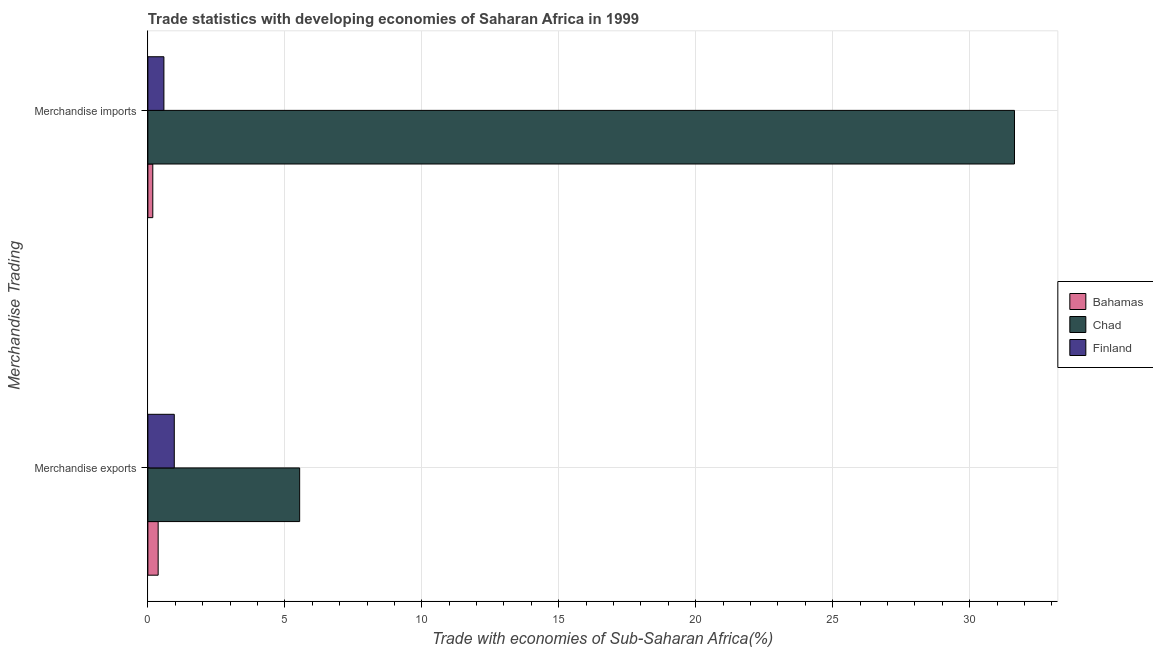How many bars are there on the 2nd tick from the top?
Your response must be concise. 3. What is the label of the 2nd group of bars from the top?
Give a very brief answer. Merchandise exports. What is the merchandise exports in Bahamas?
Your answer should be very brief. 0.38. Across all countries, what is the maximum merchandise imports?
Ensure brevity in your answer.  31.64. Across all countries, what is the minimum merchandise exports?
Give a very brief answer. 0.38. In which country was the merchandise imports maximum?
Provide a succinct answer. Chad. In which country was the merchandise imports minimum?
Keep it short and to the point. Bahamas. What is the total merchandise imports in the graph?
Your response must be concise. 32.4. What is the difference between the merchandise imports in Bahamas and that in Chad?
Offer a very short reply. -31.46. What is the difference between the merchandise exports in Finland and the merchandise imports in Bahamas?
Provide a succinct answer. 0.78. What is the average merchandise imports per country?
Offer a terse response. 10.8. What is the difference between the merchandise exports and merchandise imports in Chad?
Your response must be concise. -26.1. In how many countries, is the merchandise exports greater than 18 %?
Provide a short and direct response. 0. What is the ratio of the merchandise imports in Bahamas to that in Chad?
Offer a terse response. 0.01. In how many countries, is the merchandise exports greater than the average merchandise exports taken over all countries?
Offer a very short reply. 1. What does the 3rd bar from the top in Merchandise imports represents?
Provide a succinct answer. Bahamas. How many bars are there?
Ensure brevity in your answer.  6. What is the difference between two consecutive major ticks on the X-axis?
Make the answer very short. 5. Are the values on the major ticks of X-axis written in scientific E-notation?
Give a very brief answer. No. Does the graph contain grids?
Your answer should be compact. Yes. Where does the legend appear in the graph?
Give a very brief answer. Center right. How are the legend labels stacked?
Offer a very short reply. Vertical. What is the title of the graph?
Your answer should be very brief. Trade statistics with developing economies of Saharan Africa in 1999. Does "Lebanon" appear as one of the legend labels in the graph?
Offer a very short reply. No. What is the label or title of the X-axis?
Offer a very short reply. Trade with economies of Sub-Saharan Africa(%). What is the label or title of the Y-axis?
Your answer should be compact. Merchandise Trading. What is the Trade with economies of Sub-Saharan Africa(%) of Bahamas in Merchandise exports?
Offer a very short reply. 0.38. What is the Trade with economies of Sub-Saharan Africa(%) in Chad in Merchandise exports?
Your answer should be very brief. 5.54. What is the Trade with economies of Sub-Saharan Africa(%) in Finland in Merchandise exports?
Your response must be concise. 0.96. What is the Trade with economies of Sub-Saharan Africa(%) of Bahamas in Merchandise imports?
Provide a succinct answer. 0.18. What is the Trade with economies of Sub-Saharan Africa(%) of Chad in Merchandise imports?
Keep it short and to the point. 31.64. What is the Trade with economies of Sub-Saharan Africa(%) in Finland in Merchandise imports?
Give a very brief answer. 0.59. Across all Merchandise Trading, what is the maximum Trade with economies of Sub-Saharan Africa(%) of Bahamas?
Provide a short and direct response. 0.38. Across all Merchandise Trading, what is the maximum Trade with economies of Sub-Saharan Africa(%) in Chad?
Provide a short and direct response. 31.64. Across all Merchandise Trading, what is the maximum Trade with economies of Sub-Saharan Africa(%) in Finland?
Keep it short and to the point. 0.96. Across all Merchandise Trading, what is the minimum Trade with economies of Sub-Saharan Africa(%) of Bahamas?
Provide a succinct answer. 0.18. Across all Merchandise Trading, what is the minimum Trade with economies of Sub-Saharan Africa(%) in Chad?
Your answer should be compact. 5.54. Across all Merchandise Trading, what is the minimum Trade with economies of Sub-Saharan Africa(%) in Finland?
Make the answer very short. 0.59. What is the total Trade with economies of Sub-Saharan Africa(%) in Bahamas in the graph?
Keep it short and to the point. 0.56. What is the total Trade with economies of Sub-Saharan Africa(%) of Chad in the graph?
Offer a very short reply. 37.18. What is the total Trade with economies of Sub-Saharan Africa(%) in Finland in the graph?
Provide a short and direct response. 1.55. What is the difference between the Trade with economies of Sub-Saharan Africa(%) in Bahamas in Merchandise exports and that in Merchandise imports?
Offer a terse response. 0.2. What is the difference between the Trade with economies of Sub-Saharan Africa(%) of Chad in Merchandise exports and that in Merchandise imports?
Make the answer very short. -26.1. What is the difference between the Trade with economies of Sub-Saharan Africa(%) in Finland in Merchandise exports and that in Merchandise imports?
Make the answer very short. 0.38. What is the difference between the Trade with economies of Sub-Saharan Africa(%) of Bahamas in Merchandise exports and the Trade with economies of Sub-Saharan Africa(%) of Chad in Merchandise imports?
Provide a succinct answer. -31.26. What is the difference between the Trade with economies of Sub-Saharan Africa(%) in Bahamas in Merchandise exports and the Trade with economies of Sub-Saharan Africa(%) in Finland in Merchandise imports?
Your response must be concise. -0.21. What is the difference between the Trade with economies of Sub-Saharan Africa(%) of Chad in Merchandise exports and the Trade with economies of Sub-Saharan Africa(%) of Finland in Merchandise imports?
Offer a terse response. 4.96. What is the average Trade with economies of Sub-Saharan Africa(%) in Bahamas per Merchandise Trading?
Ensure brevity in your answer.  0.28. What is the average Trade with economies of Sub-Saharan Africa(%) of Chad per Merchandise Trading?
Provide a short and direct response. 18.59. What is the average Trade with economies of Sub-Saharan Africa(%) in Finland per Merchandise Trading?
Provide a succinct answer. 0.78. What is the difference between the Trade with economies of Sub-Saharan Africa(%) of Bahamas and Trade with economies of Sub-Saharan Africa(%) of Chad in Merchandise exports?
Provide a succinct answer. -5.17. What is the difference between the Trade with economies of Sub-Saharan Africa(%) of Bahamas and Trade with economies of Sub-Saharan Africa(%) of Finland in Merchandise exports?
Give a very brief answer. -0.59. What is the difference between the Trade with economies of Sub-Saharan Africa(%) in Chad and Trade with economies of Sub-Saharan Africa(%) in Finland in Merchandise exports?
Your response must be concise. 4.58. What is the difference between the Trade with economies of Sub-Saharan Africa(%) in Bahamas and Trade with economies of Sub-Saharan Africa(%) in Chad in Merchandise imports?
Provide a short and direct response. -31.46. What is the difference between the Trade with economies of Sub-Saharan Africa(%) of Bahamas and Trade with economies of Sub-Saharan Africa(%) of Finland in Merchandise imports?
Your response must be concise. -0.41. What is the difference between the Trade with economies of Sub-Saharan Africa(%) of Chad and Trade with economies of Sub-Saharan Africa(%) of Finland in Merchandise imports?
Give a very brief answer. 31.05. What is the ratio of the Trade with economies of Sub-Saharan Africa(%) in Bahamas in Merchandise exports to that in Merchandise imports?
Ensure brevity in your answer.  2.08. What is the ratio of the Trade with economies of Sub-Saharan Africa(%) of Chad in Merchandise exports to that in Merchandise imports?
Keep it short and to the point. 0.18. What is the ratio of the Trade with economies of Sub-Saharan Africa(%) of Finland in Merchandise exports to that in Merchandise imports?
Provide a short and direct response. 1.65. What is the difference between the highest and the second highest Trade with economies of Sub-Saharan Africa(%) in Bahamas?
Provide a succinct answer. 0.2. What is the difference between the highest and the second highest Trade with economies of Sub-Saharan Africa(%) of Chad?
Make the answer very short. 26.1. What is the difference between the highest and the second highest Trade with economies of Sub-Saharan Africa(%) in Finland?
Ensure brevity in your answer.  0.38. What is the difference between the highest and the lowest Trade with economies of Sub-Saharan Africa(%) in Bahamas?
Your answer should be very brief. 0.2. What is the difference between the highest and the lowest Trade with economies of Sub-Saharan Africa(%) of Chad?
Your answer should be compact. 26.1. What is the difference between the highest and the lowest Trade with economies of Sub-Saharan Africa(%) of Finland?
Your response must be concise. 0.38. 